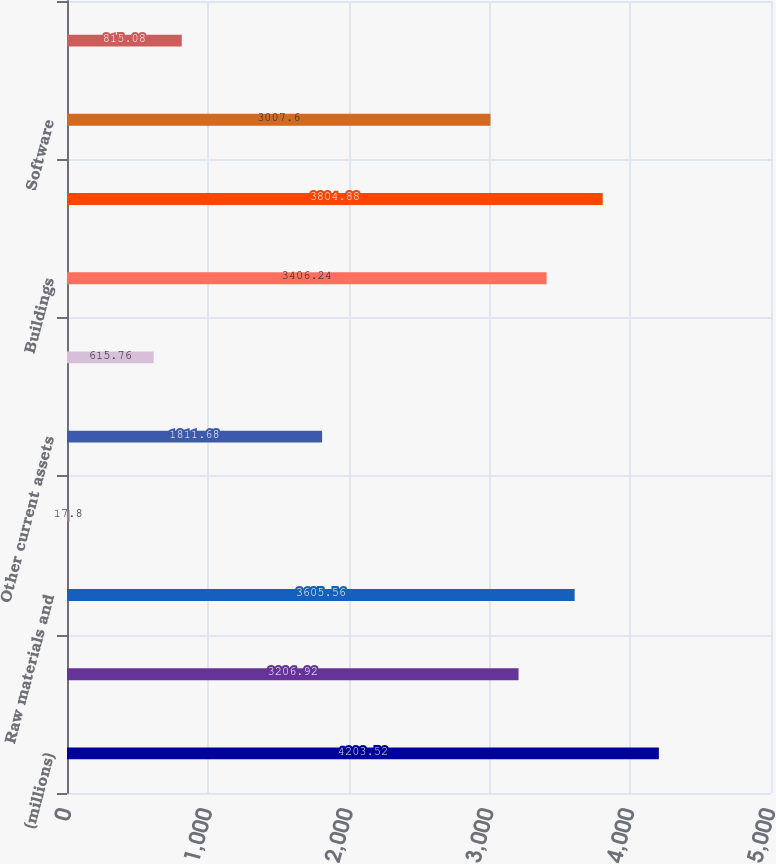Convert chart to OTSL. <chart><loc_0><loc_0><loc_500><loc_500><bar_chart><fcel>(millions)<fcel>Finished products<fcel>Raw materials and<fcel>Prepaid expenses<fcel>Other current assets<fcel>Land and improvements<fcel>Buildings<fcel>Machinery and equipment<fcel>Software<fcel>Construction-in-progress<nl><fcel>4203.52<fcel>3206.92<fcel>3605.56<fcel>17.8<fcel>1811.68<fcel>615.76<fcel>3406.24<fcel>3804.88<fcel>3007.6<fcel>815.08<nl></chart> 